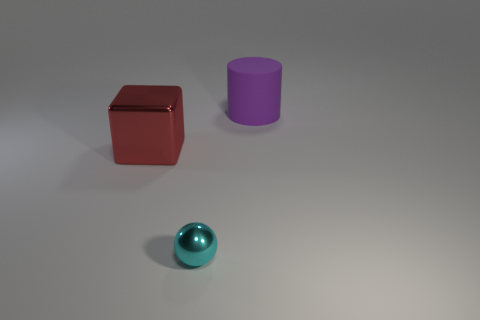Does the large cylinder have the same color as the metallic ball?
Offer a terse response. No. Are there more things that are right of the large shiny thing than small cyan things behind the tiny cyan sphere?
Ensure brevity in your answer.  Yes. Is the color of the large thing in front of the purple cylinder the same as the matte cylinder?
Your answer should be very brief. No. Are there any other things that have the same color as the small thing?
Provide a short and direct response. No. Is the number of red metal objects that are in front of the large purple object greater than the number of red metallic blocks?
Offer a terse response. No. Is the size of the cube the same as the cylinder?
Offer a very short reply. Yes. Is there anything else that is the same material as the purple thing?
Your response must be concise. No. How many green objects are small things or big shiny blocks?
Provide a short and direct response. 0. What is the material of the thing that is to the left of the tiny cyan ball?
Give a very brief answer. Metal. Is the number of small cyan things greater than the number of large things?
Your answer should be compact. No. 